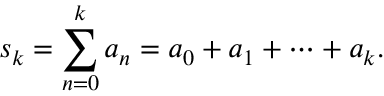<formula> <loc_0><loc_0><loc_500><loc_500>s _ { k } = \sum _ { n = 0 } ^ { k } a _ { n } = a _ { 0 } + a _ { 1 } + \cdots + a _ { k } .</formula> 